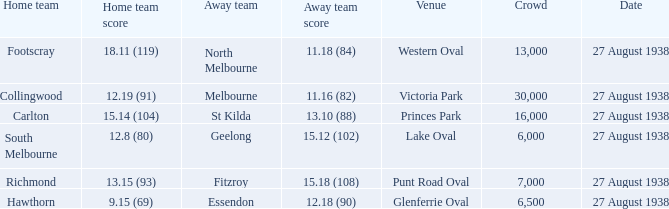What is the average crowd attendance for Collingwood? 30000.0. 